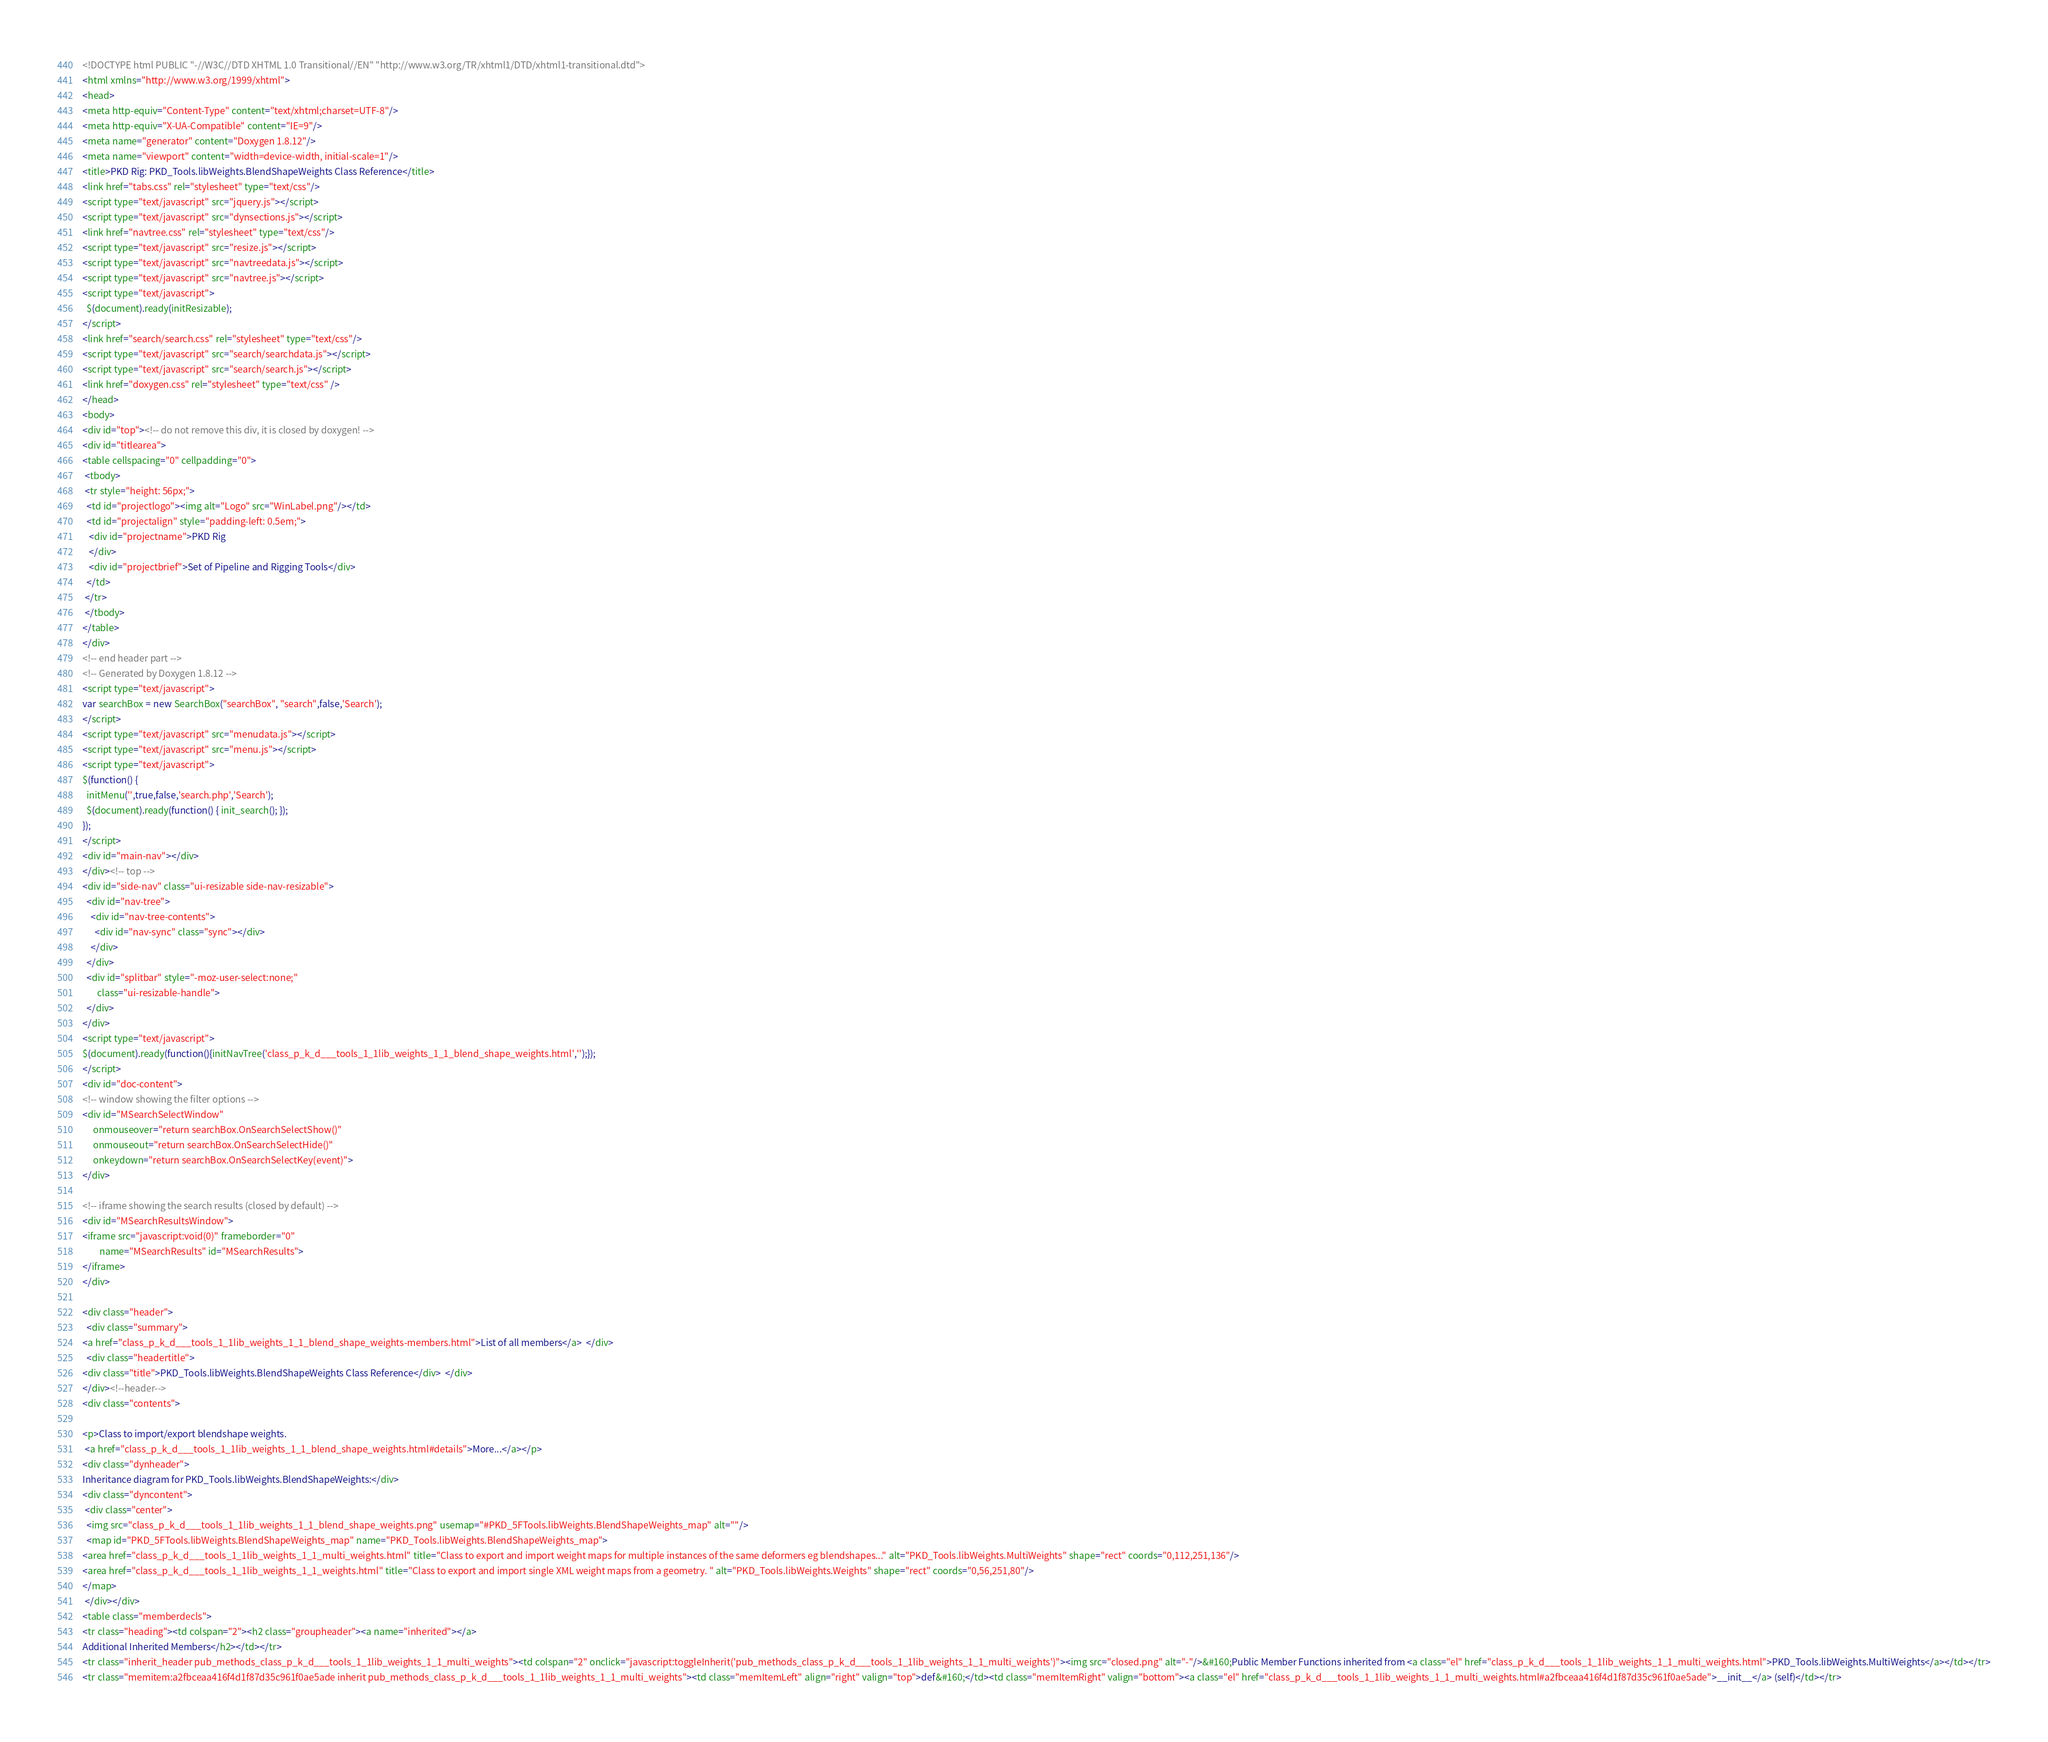Convert code to text. <code><loc_0><loc_0><loc_500><loc_500><_HTML_><!DOCTYPE html PUBLIC "-//W3C//DTD XHTML 1.0 Transitional//EN" "http://www.w3.org/TR/xhtml1/DTD/xhtml1-transitional.dtd">
<html xmlns="http://www.w3.org/1999/xhtml">
<head>
<meta http-equiv="Content-Type" content="text/xhtml;charset=UTF-8"/>
<meta http-equiv="X-UA-Compatible" content="IE=9"/>
<meta name="generator" content="Doxygen 1.8.12"/>
<meta name="viewport" content="width=device-width, initial-scale=1"/>
<title>PKD Rig: PKD_Tools.libWeights.BlendShapeWeights Class Reference</title>
<link href="tabs.css" rel="stylesheet" type="text/css"/>
<script type="text/javascript" src="jquery.js"></script>
<script type="text/javascript" src="dynsections.js"></script>
<link href="navtree.css" rel="stylesheet" type="text/css"/>
<script type="text/javascript" src="resize.js"></script>
<script type="text/javascript" src="navtreedata.js"></script>
<script type="text/javascript" src="navtree.js"></script>
<script type="text/javascript">
  $(document).ready(initResizable);
</script>
<link href="search/search.css" rel="stylesheet" type="text/css"/>
<script type="text/javascript" src="search/searchdata.js"></script>
<script type="text/javascript" src="search/search.js"></script>
<link href="doxygen.css" rel="stylesheet" type="text/css" />
</head>
<body>
<div id="top"><!-- do not remove this div, it is closed by doxygen! -->
<div id="titlearea">
<table cellspacing="0" cellpadding="0">
 <tbody>
 <tr style="height: 56px;">
  <td id="projectlogo"><img alt="Logo" src="WinLabel.png"/></td>
  <td id="projectalign" style="padding-left: 0.5em;">
   <div id="projectname">PKD Rig
   </div>
   <div id="projectbrief">Set of Pipeline and Rigging Tools</div>
  </td>
 </tr>
 </tbody>
</table>
</div>
<!-- end header part -->
<!-- Generated by Doxygen 1.8.12 -->
<script type="text/javascript">
var searchBox = new SearchBox("searchBox", "search",false,'Search');
</script>
<script type="text/javascript" src="menudata.js"></script>
<script type="text/javascript" src="menu.js"></script>
<script type="text/javascript">
$(function() {
  initMenu('',true,false,'search.php','Search');
  $(document).ready(function() { init_search(); });
});
</script>
<div id="main-nav"></div>
</div><!-- top -->
<div id="side-nav" class="ui-resizable side-nav-resizable">
  <div id="nav-tree">
    <div id="nav-tree-contents">
      <div id="nav-sync" class="sync"></div>
    </div>
  </div>
  <div id="splitbar" style="-moz-user-select:none;" 
       class="ui-resizable-handle">
  </div>
</div>
<script type="text/javascript">
$(document).ready(function(){initNavTree('class_p_k_d___tools_1_1lib_weights_1_1_blend_shape_weights.html','');});
</script>
<div id="doc-content">
<!-- window showing the filter options -->
<div id="MSearchSelectWindow"
     onmouseover="return searchBox.OnSearchSelectShow()"
     onmouseout="return searchBox.OnSearchSelectHide()"
     onkeydown="return searchBox.OnSearchSelectKey(event)">
</div>

<!-- iframe showing the search results (closed by default) -->
<div id="MSearchResultsWindow">
<iframe src="javascript:void(0)" frameborder="0" 
        name="MSearchResults" id="MSearchResults">
</iframe>
</div>

<div class="header">
  <div class="summary">
<a href="class_p_k_d___tools_1_1lib_weights_1_1_blend_shape_weights-members.html">List of all members</a>  </div>
  <div class="headertitle">
<div class="title">PKD_Tools.libWeights.BlendShapeWeights Class Reference</div>  </div>
</div><!--header-->
<div class="contents">

<p>Class to import/export blendshape weights.  
 <a href="class_p_k_d___tools_1_1lib_weights_1_1_blend_shape_weights.html#details">More...</a></p>
<div class="dynheader">
Inheritance diagram for PKD_Tools.libWeights.BlendShapeWeights:</div>
<div class="dyncontent">
 <div class="center">
  <img src="class_p_k_d___tools_1_1lib_weights_1_1_blend_shape_weights.png" usemap="#PKD_5FTools.libWeights.BlendShapeWeights_map" alt=""/>
  <map id="PKD_5FTools.libWeights.BlendShapeWeights_map" name="PKD_Tools.libWeights.BlendShapeWeights_map">
<area href="class_p_k_d___tools_1_1lib_weights_1_1_multi_weights.html" title="Class to export and import weight maps for multiple instances of the same deformers eg blendshapes..." alt="PKD_Tools.libWeights.MultiWeights" shape="rect" coords="0,112,251,136"/>
<area href="class_p_k_d___tools_1_1lib_weights_1_1_weights.html" title="Class to export and import single XML weight maps from a geometry. " alt="PKD_Tools.libWeights.Weights" shape="rect" coords="0,56,251,80"/>
</map>
 </div></div>
<table class="memberdecls">
<tr class="heading"><td colspan="2"><h2 class="groupheader"><a name="inherited"></a>
Additional Inherited Members</h2></td></tr>
<tr class="inherit_header pub_methods_class_p_k_d___tools_1_1lib_weights_1_1_multi_weights"><td colspan="2" onclick="javascript:toggleInherit('pub_methods_class_p_k_d___tools_1_1lib_weights_1_1_multi_weights')"><img src="closed.png" alt="-"/>&#160;Public Member Functions inherited from <a class="el" href="class_p_k_d___tools_1_1lib_weights_1_1_multi_weights.html">PKD_Tools.libWeights.MultiWeights</a></td></tr>
<tr class="memitem:a2fbceaa416f4d1f87d35c961f0ae5ade inherit pub_methods_class_p_k_d___tools_1_1lib_weights_1_1_multi_weights"><td class="memItemLeft" align="right" valign="top">def&#160;</td><td class="memItemRight" valign="bottom"><a class="el" href="class_p_k_d___tools_1_1lib_weights_1_1_multi_weights.html#a2fbceaa416f4d1f87d35c961f0ae5ade">__init__</a> (self)</td></tr></code> 